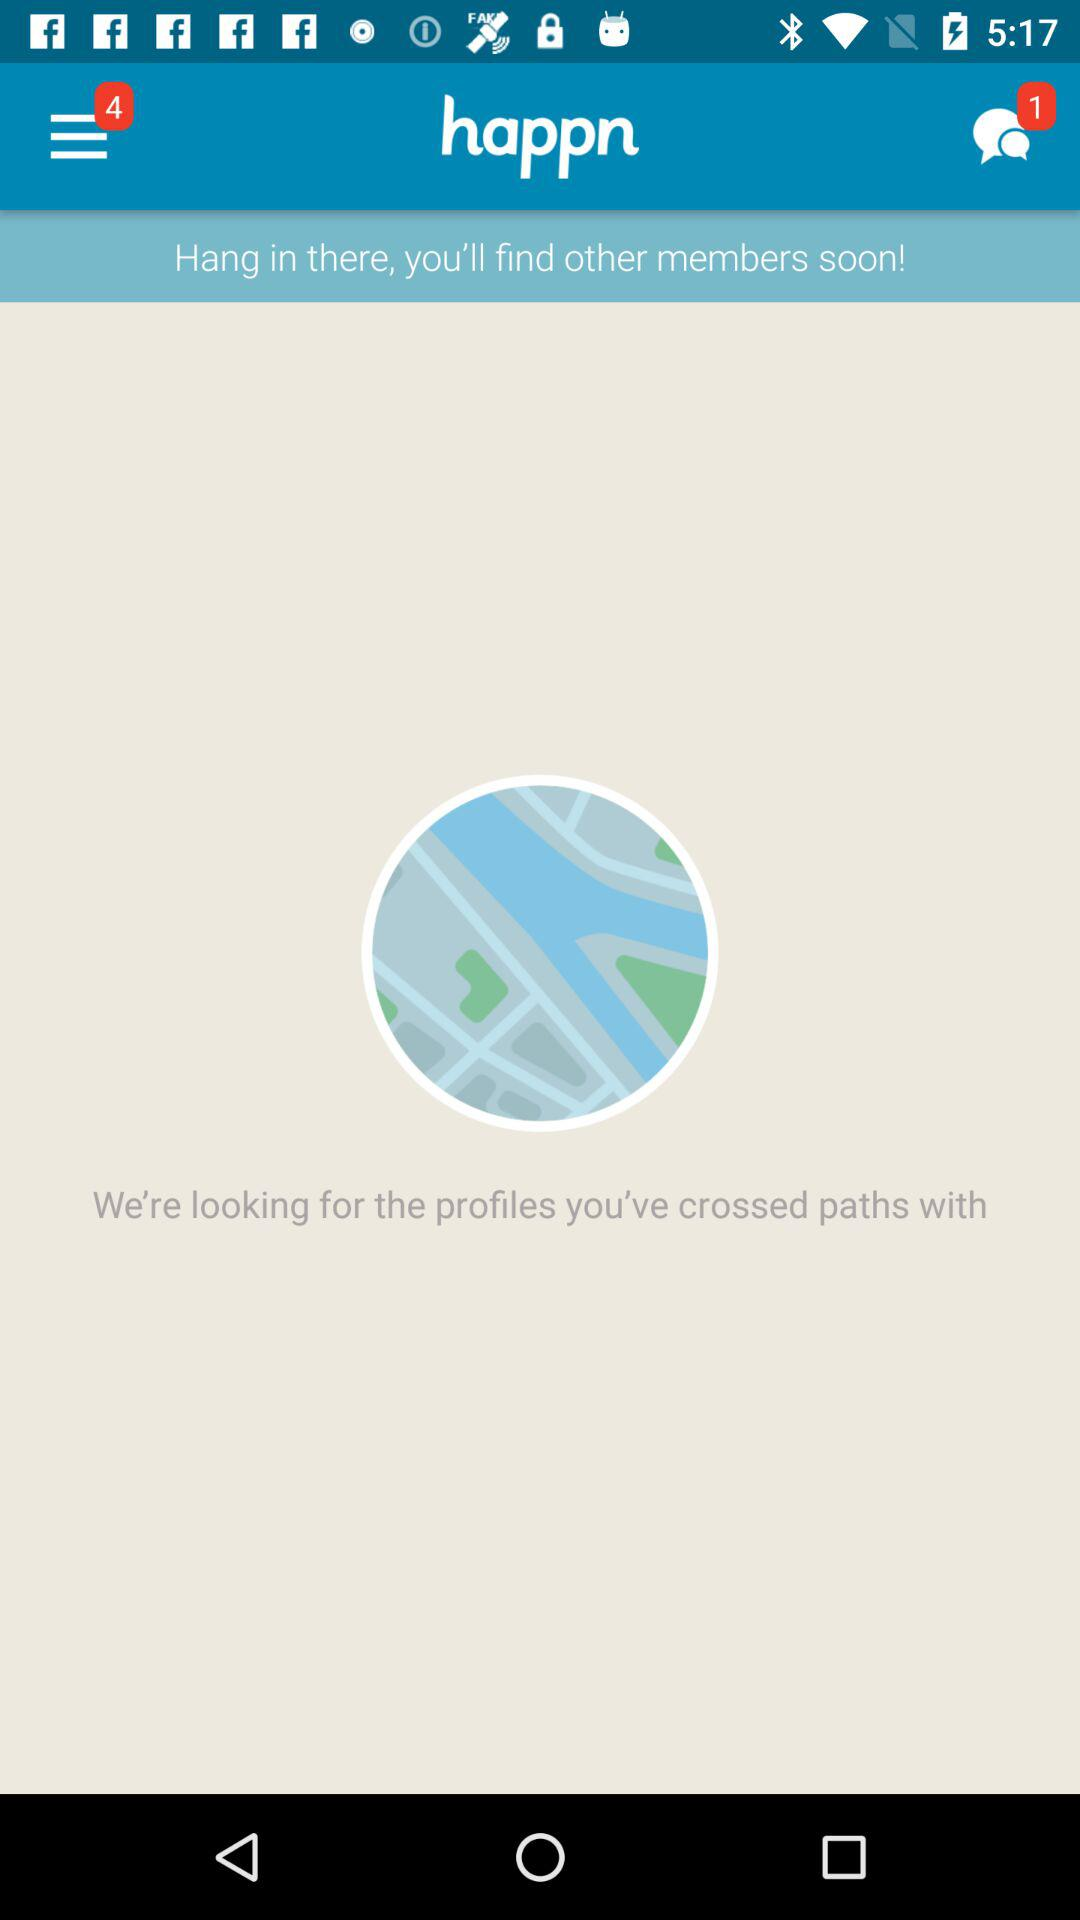What's the number of unread chats? The number of unread chats is 1. 